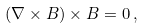Convert formula to latex. <formula><loc_0><loc_0><loc_500><loc_500>( \nabla \times { B } ) \times { B } = 0 \, ,</formula> 